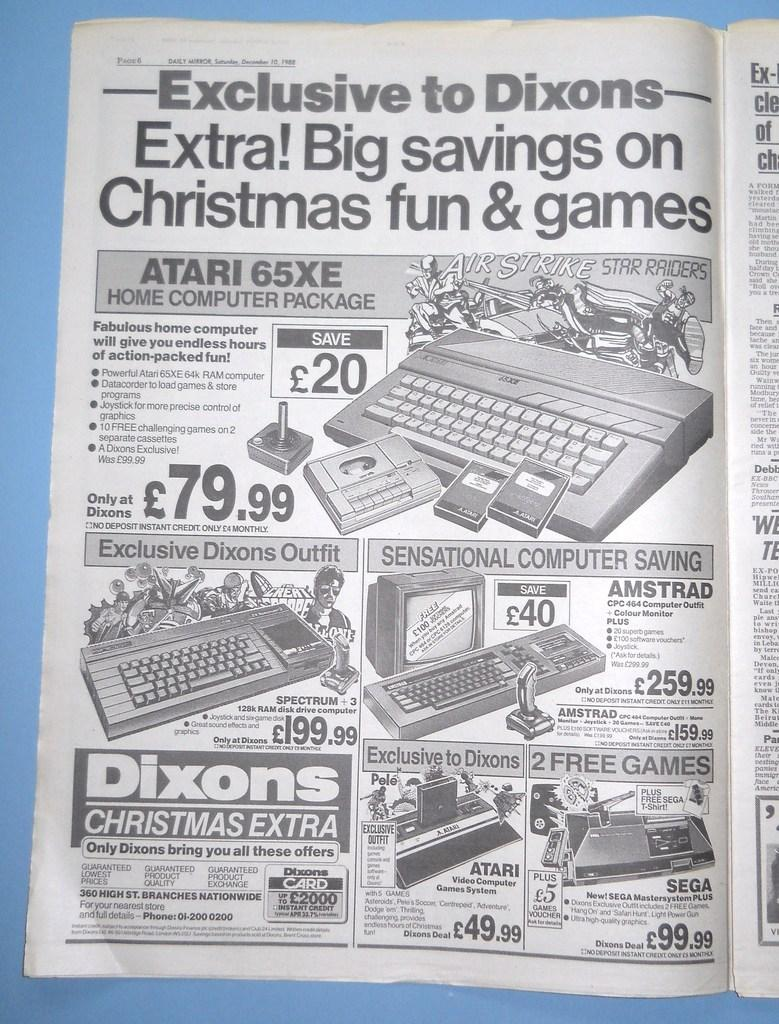<image>
Create a compact narrative representing the image presented. A black and white advertisements shows items available on sale at Dixons. 